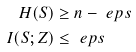<formula> <loc_0><loc_0><loc_500><loc_500>H ( S ) & \geq n - \ e p s \\ I ( S ; Z ) & \leq \ e p s</formula> 